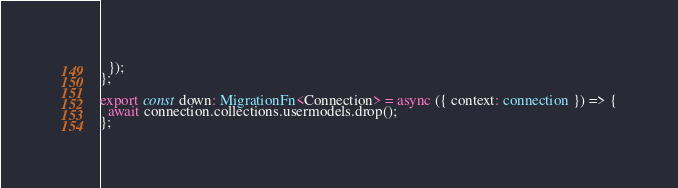Convert code to text. <code><loc_0><loc_0><loc_500><loc_500><_TypeScript_>  });
};

export const down: MigrationFn<Connection> = async ({ context: connection }) => {
  await connection.collections.usermodels.drop();
};
</code> 